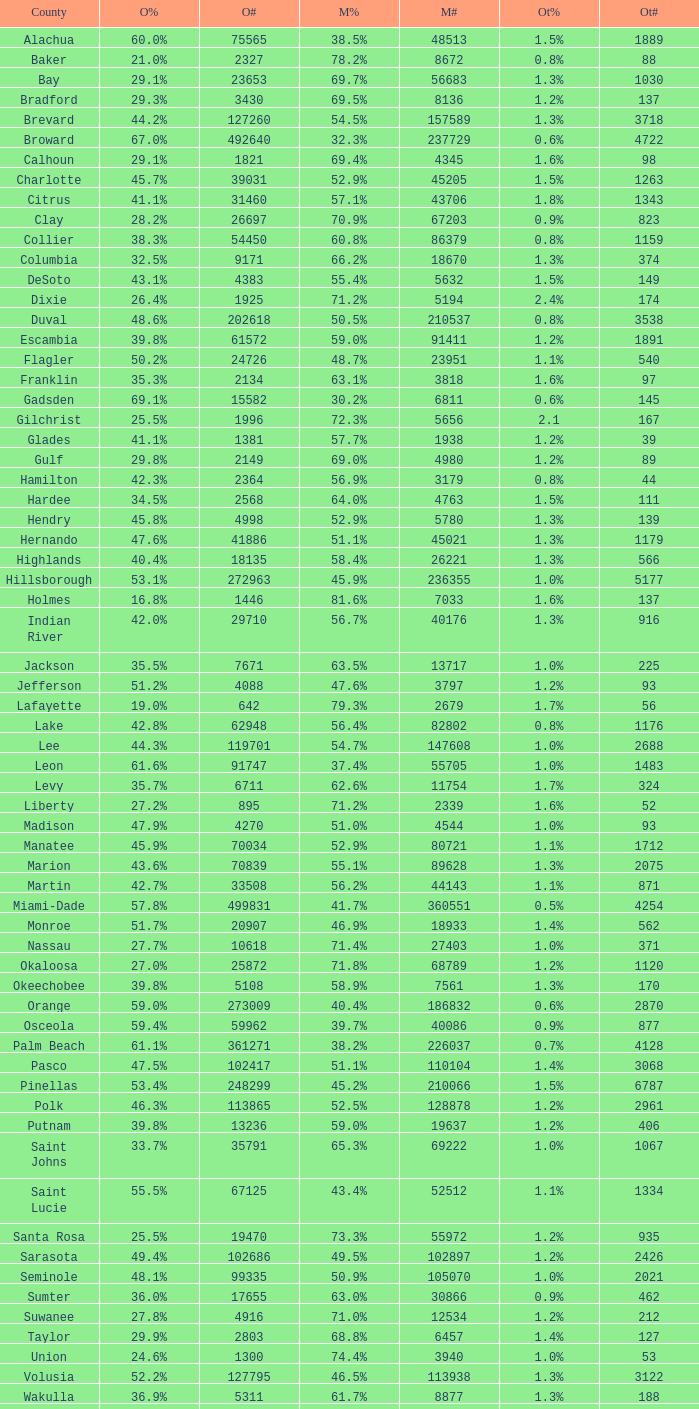What percentage was the others vote when McCain had 52.9% and less than 45205.0 voters? 1.3%. 